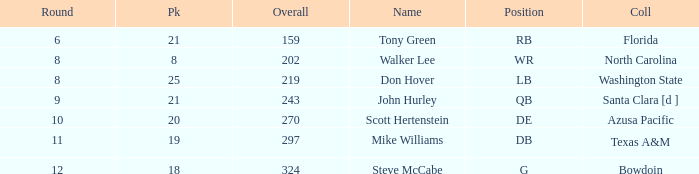What is the average overall that has a pick less than 20, North Carolina as the college, with a round less than 8? None. 